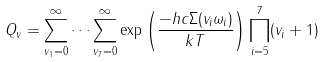<formula> <loc_0><loc_0><loc_500><loc_500>Q _ { v } = \sum _ { v _ { 1 } = 0 } ^ { \infty } \dots \sum _ { v _ { 7 } = 0 } ^ { \infty } \exp \left ( \frac { - h c \Sigma ( v _ { i } \omega _ { i } ) } { k T } \right ) \prod _ { i = 5 } ^ { 7 } ( v _ { i } + 1 )</formula> 